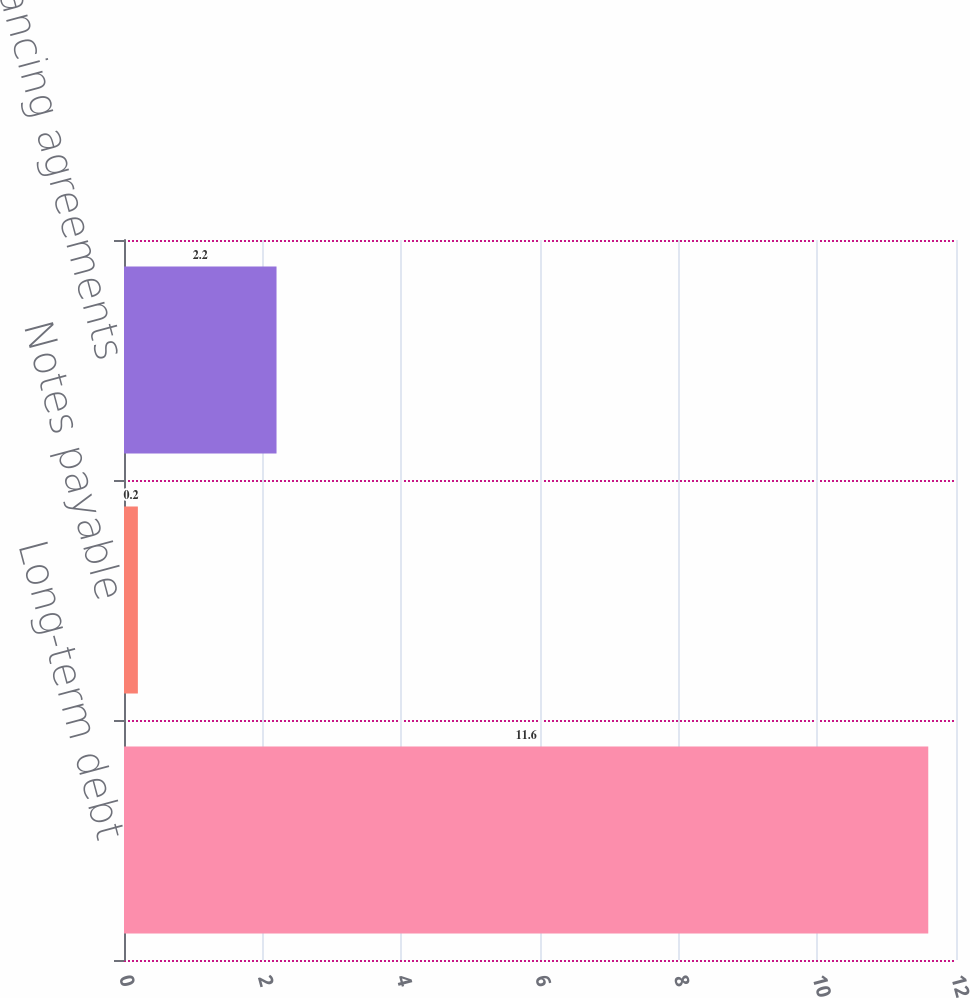Convert chart to OTSL. <chart><loc_0><loc_0><loc_500><loc_500><bar_chart><fcel>Long-term debt<fcel>Notes payable<fcel>Fees on financing agreements<nl><fcel>11.6<fcel>0.2<fcel>2.2<nl></chart> 